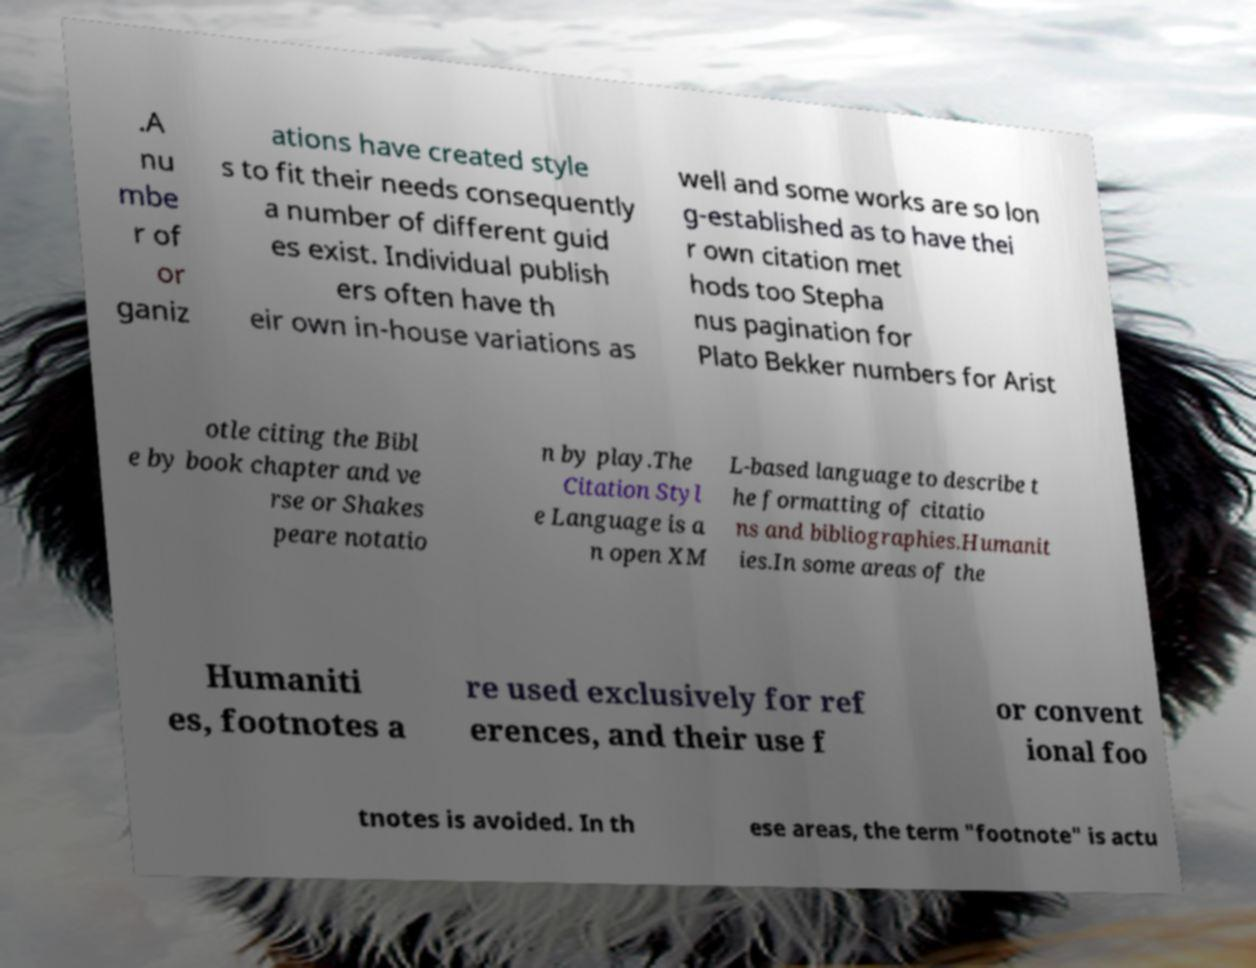For documentation purposes, I need the text within this image transcribed. Could you provide that? .A nu mbe r of or ganiz ations have created style s to fit their needs consequently a number of different guid es exist. Individual publish ers often have th eir own in-house variations as well and some works are so lon g-established as to have thei r own citation met hods too Stepha nus pagination for Plato Bekker numbers for Arist otle citing the Bibl e by book chapter and ve rse or Shakes peare notatio n by play.The Citation Styl e Language is a n open XM L-based language to describe t he formatting of citatio ns and bibliographies.Humanit ies.In some areas of the Humaniti es, footnotes a re used exclusively for ref erences, and their use f or convent ional foo tnotes is avoided. In th ese areas, the term "footnote" is actu 